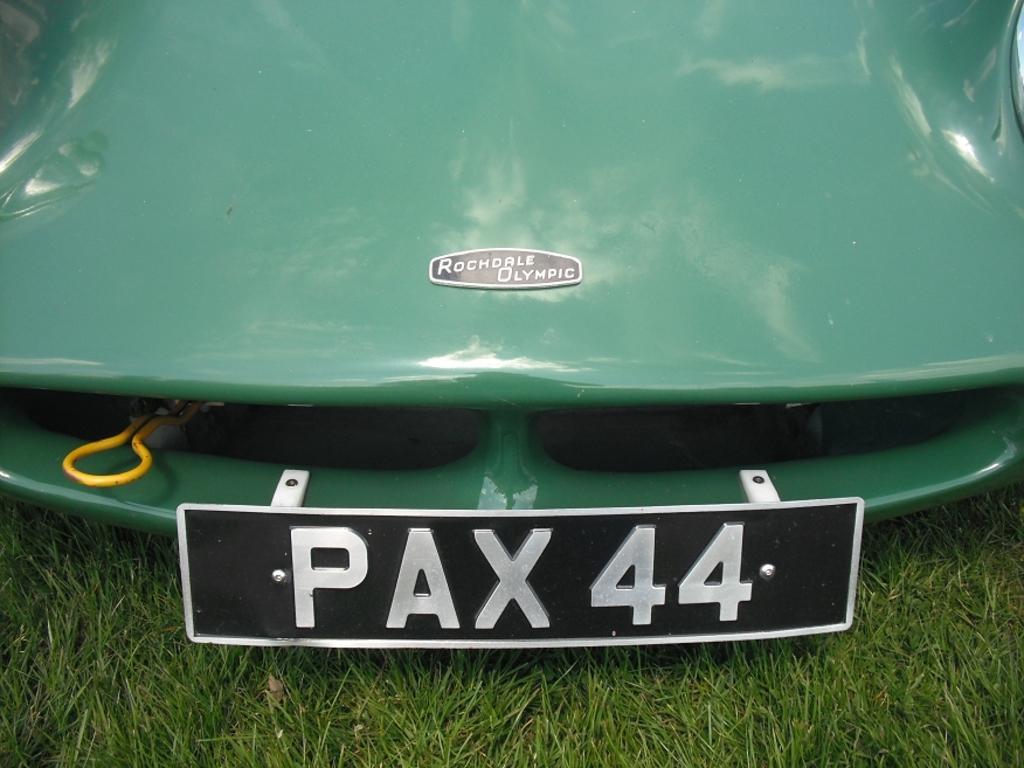What is the license plate number?
Your answer should be very brief. Pax44. What is the plate number?
Offer a terse response. Pax44. 